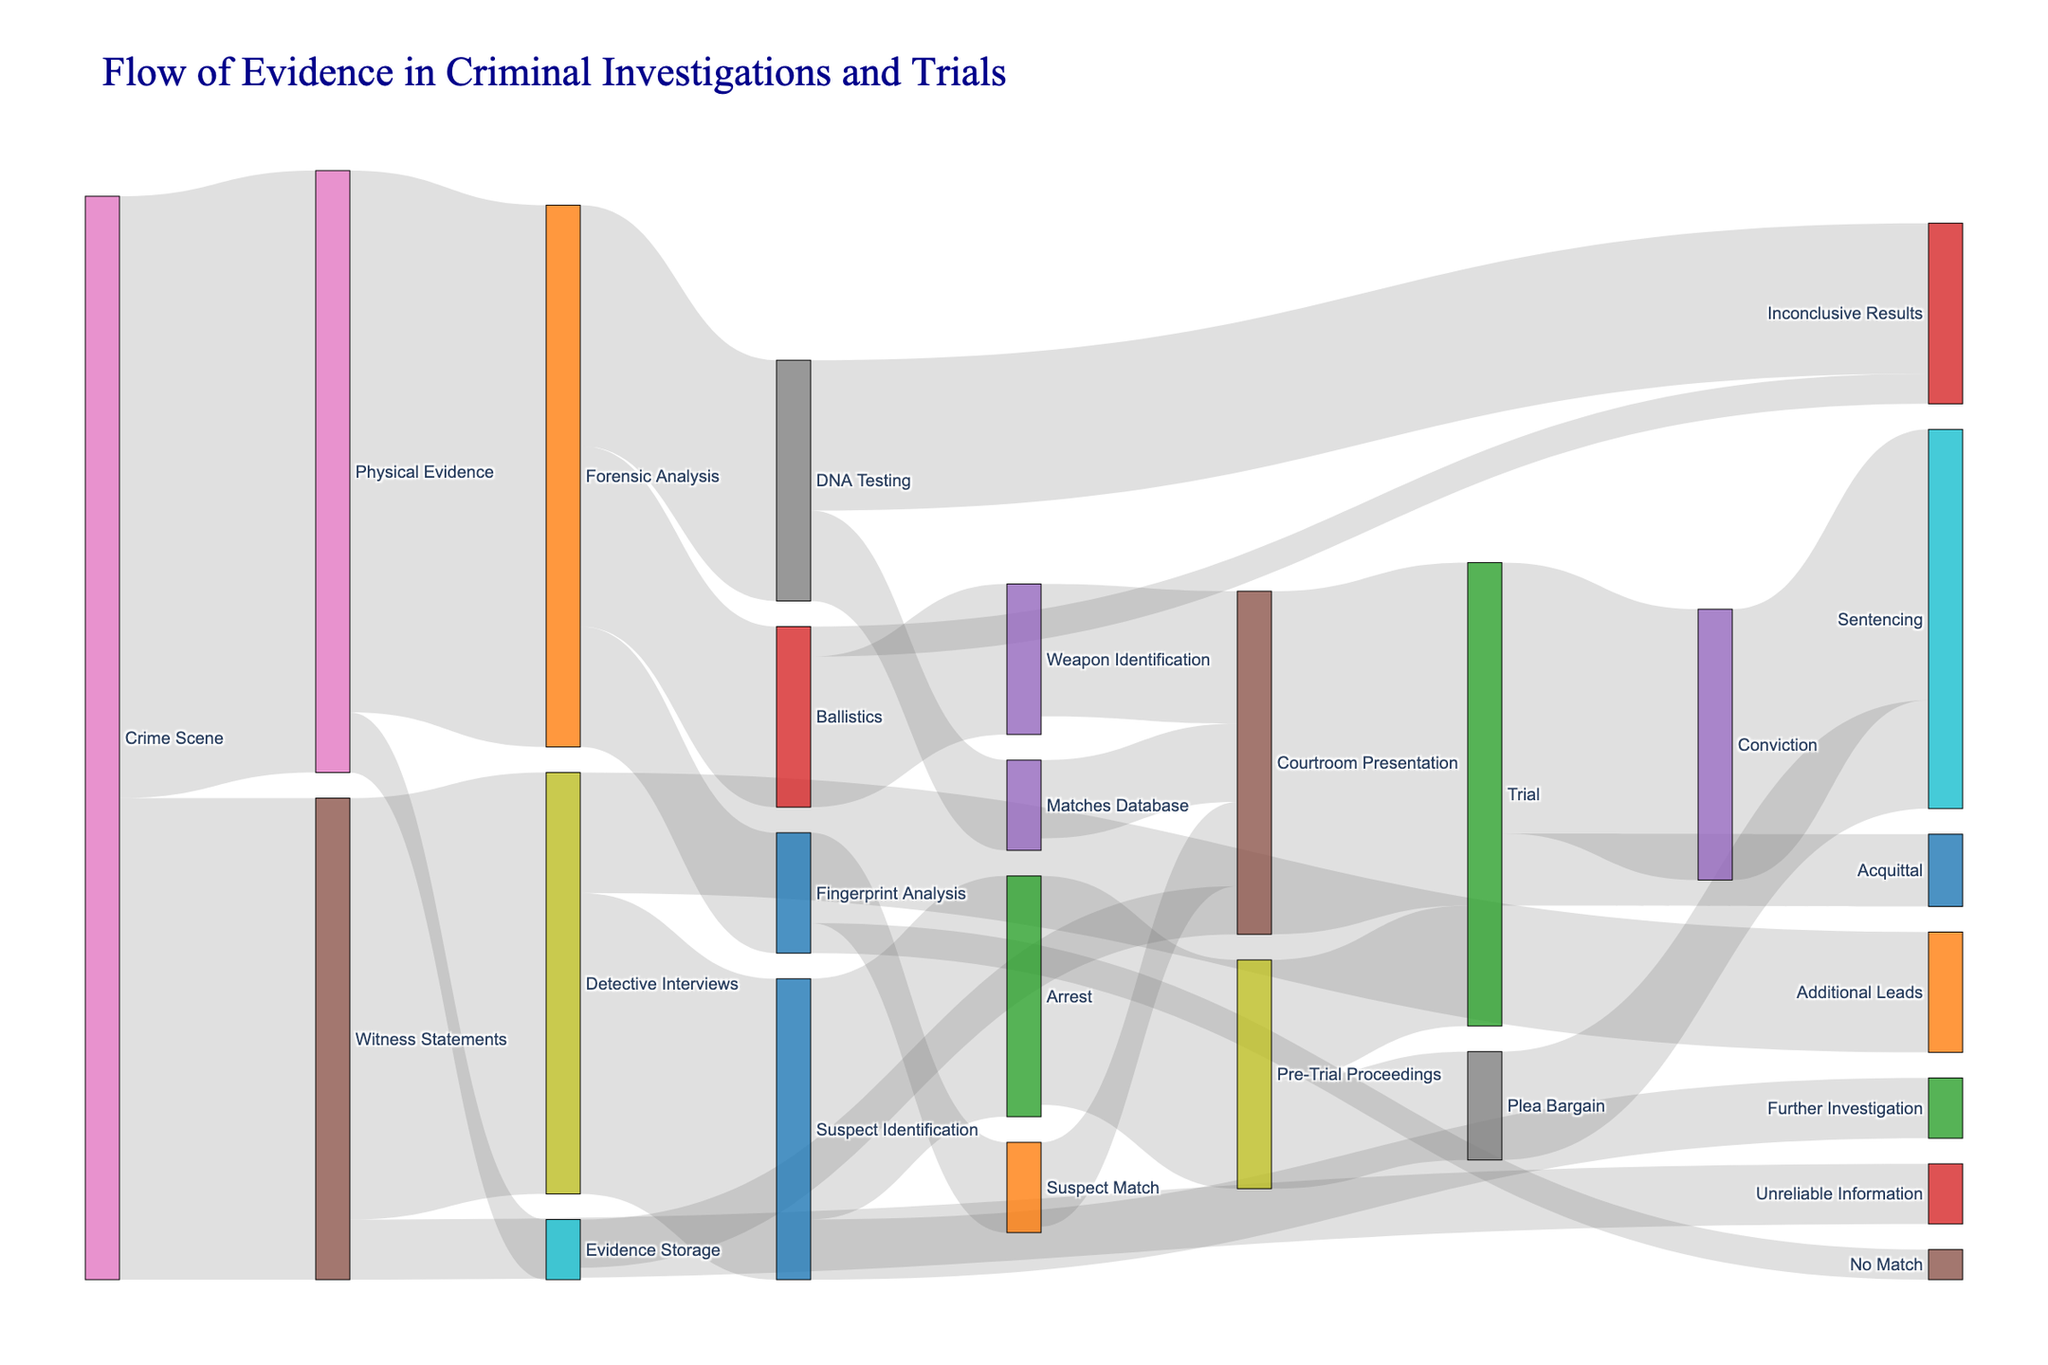What is the title of the figure? The title is prominently displayed at the top of the figure, providing an overview of the subject matter. It is displayed in a dark blue color and a large, readable font.
Answer: "Flow of Evidence in Criminal Investigations and Trials" How many paths flow from Detective Interviews to Suspect Identification? In the Sankey Diagram, observe the lines (or links) connecting "Detective Interviews" to its subsequent steps. We see that it connects to "Suspect Identification" once, with a singular path leading from Detective Interviews to Suspect Identification.
Answer: 1 Which stage receives the maximum flow of evidence from Physical Evidence? The widths of the lines from "Physical Evidence" to its target stages must be compared. The flow to "Forensic Analysis" appears thicker than the flow to "Evidence Storage." This implies a greater value or quantity. According to the figure, 900 units flow to "Forensic Analysis."
Answer: Forensic Analysis What happens to the evidence categorized under DNA Testing that doesn't result in a match? Look at the flows coming from "DNA Testing." The choices are "Matches Database" and "Inconclusive Results." Since "Matches Database" implies a match, evidence falling under "Inconclusive Results" does not result in a match.
Answer: Inconclusive Results How many units of evidence proceed from Forensic Analysis to Fingerprint Analysis? Trace the thickness of the lines leading from "Forensic Analysis" and find the one pointing to "Fingerprint Analysis." This visual representation will show the corresponding value. According to the diagram, it is 200 units.
Answer: 200 Compare the number of units leading to trial from courtroom presentation against those leading to trial from pre-trial proceedings. Which pathway contributes more? Evaluate the flows from both "Courtroom Presentation" and "Pre-Trial Proceedings" towards "Trial." Adding up the values, we find that "Courtroom Presentation" proceeds directly to "Trial" with 570 units, while from "Pre-Trial Proceedings," this is 200 units.
Answer: Courtroom Presentation What are two possible outcomes from the stage of trial? The Sankey Diagram showcases two separate flows from the "Trial" stage, leading into different outcomes. The stage labeled "Trial" leads to both "Conviction" and "Acquittal."
Answer: Conviction and Acquittal If evidence starts from the Crime Scene, list the stages it passes through before reaching the Sentencing stage. Trace the pathways for evidence emanating from "Crime Scene," focusing on sequences that lead to "Sentencing." The pattern involves multiple consecutive steps: (1) Crime Scene to Physical Evidence, (2) Physical Evidence to Forensic Analysis, (3) Forensic Analysis undergoes various analyses like DNA, Ballistics, or Fingerprint Analysis, (4) then a match leading to Suspect Identification or direct to Courtroom Presentation, (5) Courtroom Presentation to Trial, (6) and finally leading to "Conviction" followed by "Sentencing." Another path could be through Pre-Trial Proceedings and Plea Bargain.
Answer: Multiple stages, depending on the specific paths. Examples include: Crime Scene -> Physical Evidence -> Forensic Analysis -> DNA Testing -> Matches Database -> Courtroom Presentation -> Trial -> Conviction -> Sentencing What is the flow from Witness Statements to Potentially Unreliable Information? Is this proportionally significant? Look for the line connecting "Witness Statements" to "Unreliable Information." The width of the line, indicating the volume of flow, is 100 units. Relative to the total 800 units coming from "Witness Statements," 100 is a minor proportion (about 12.5%). This is visualized by a thin line.
Answer: 100 units, minor proportion 